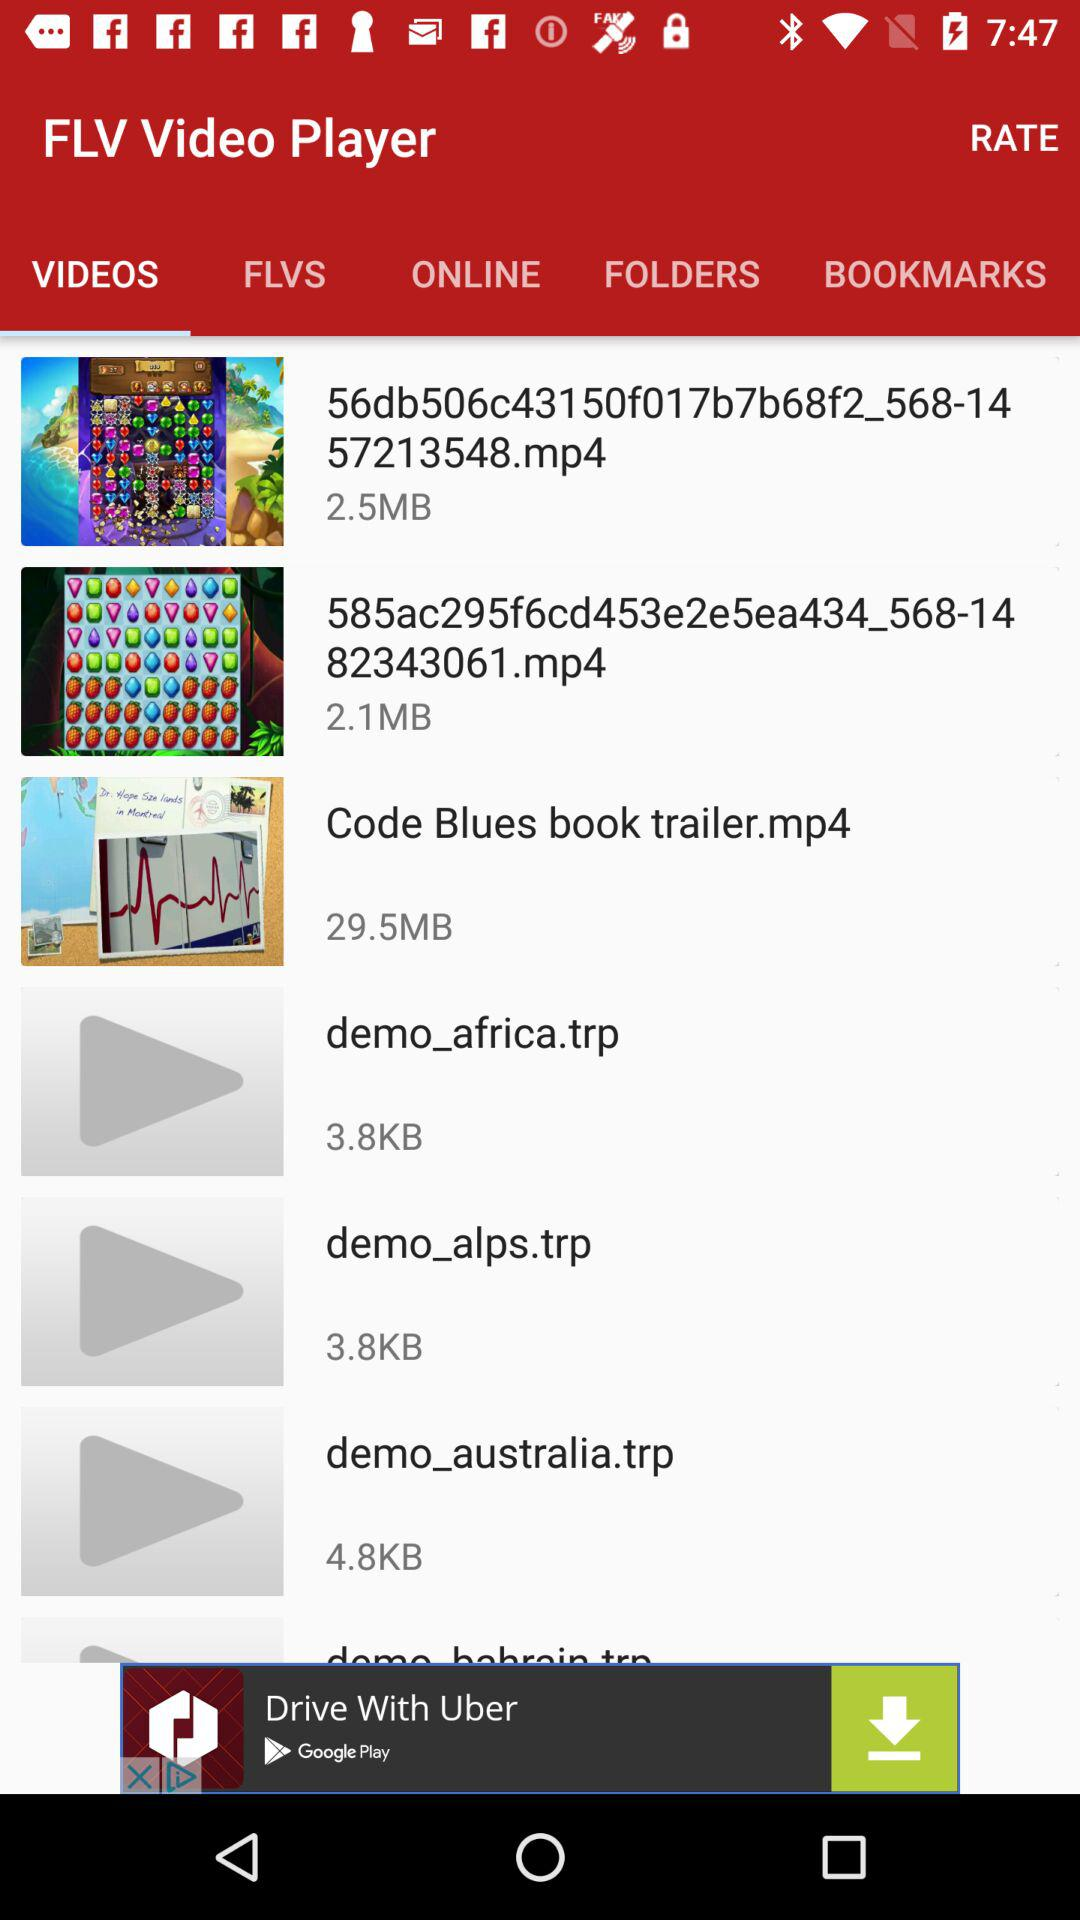What is the size of "Code Blues book trailer.mp4"? The size is 29.5 MB. 